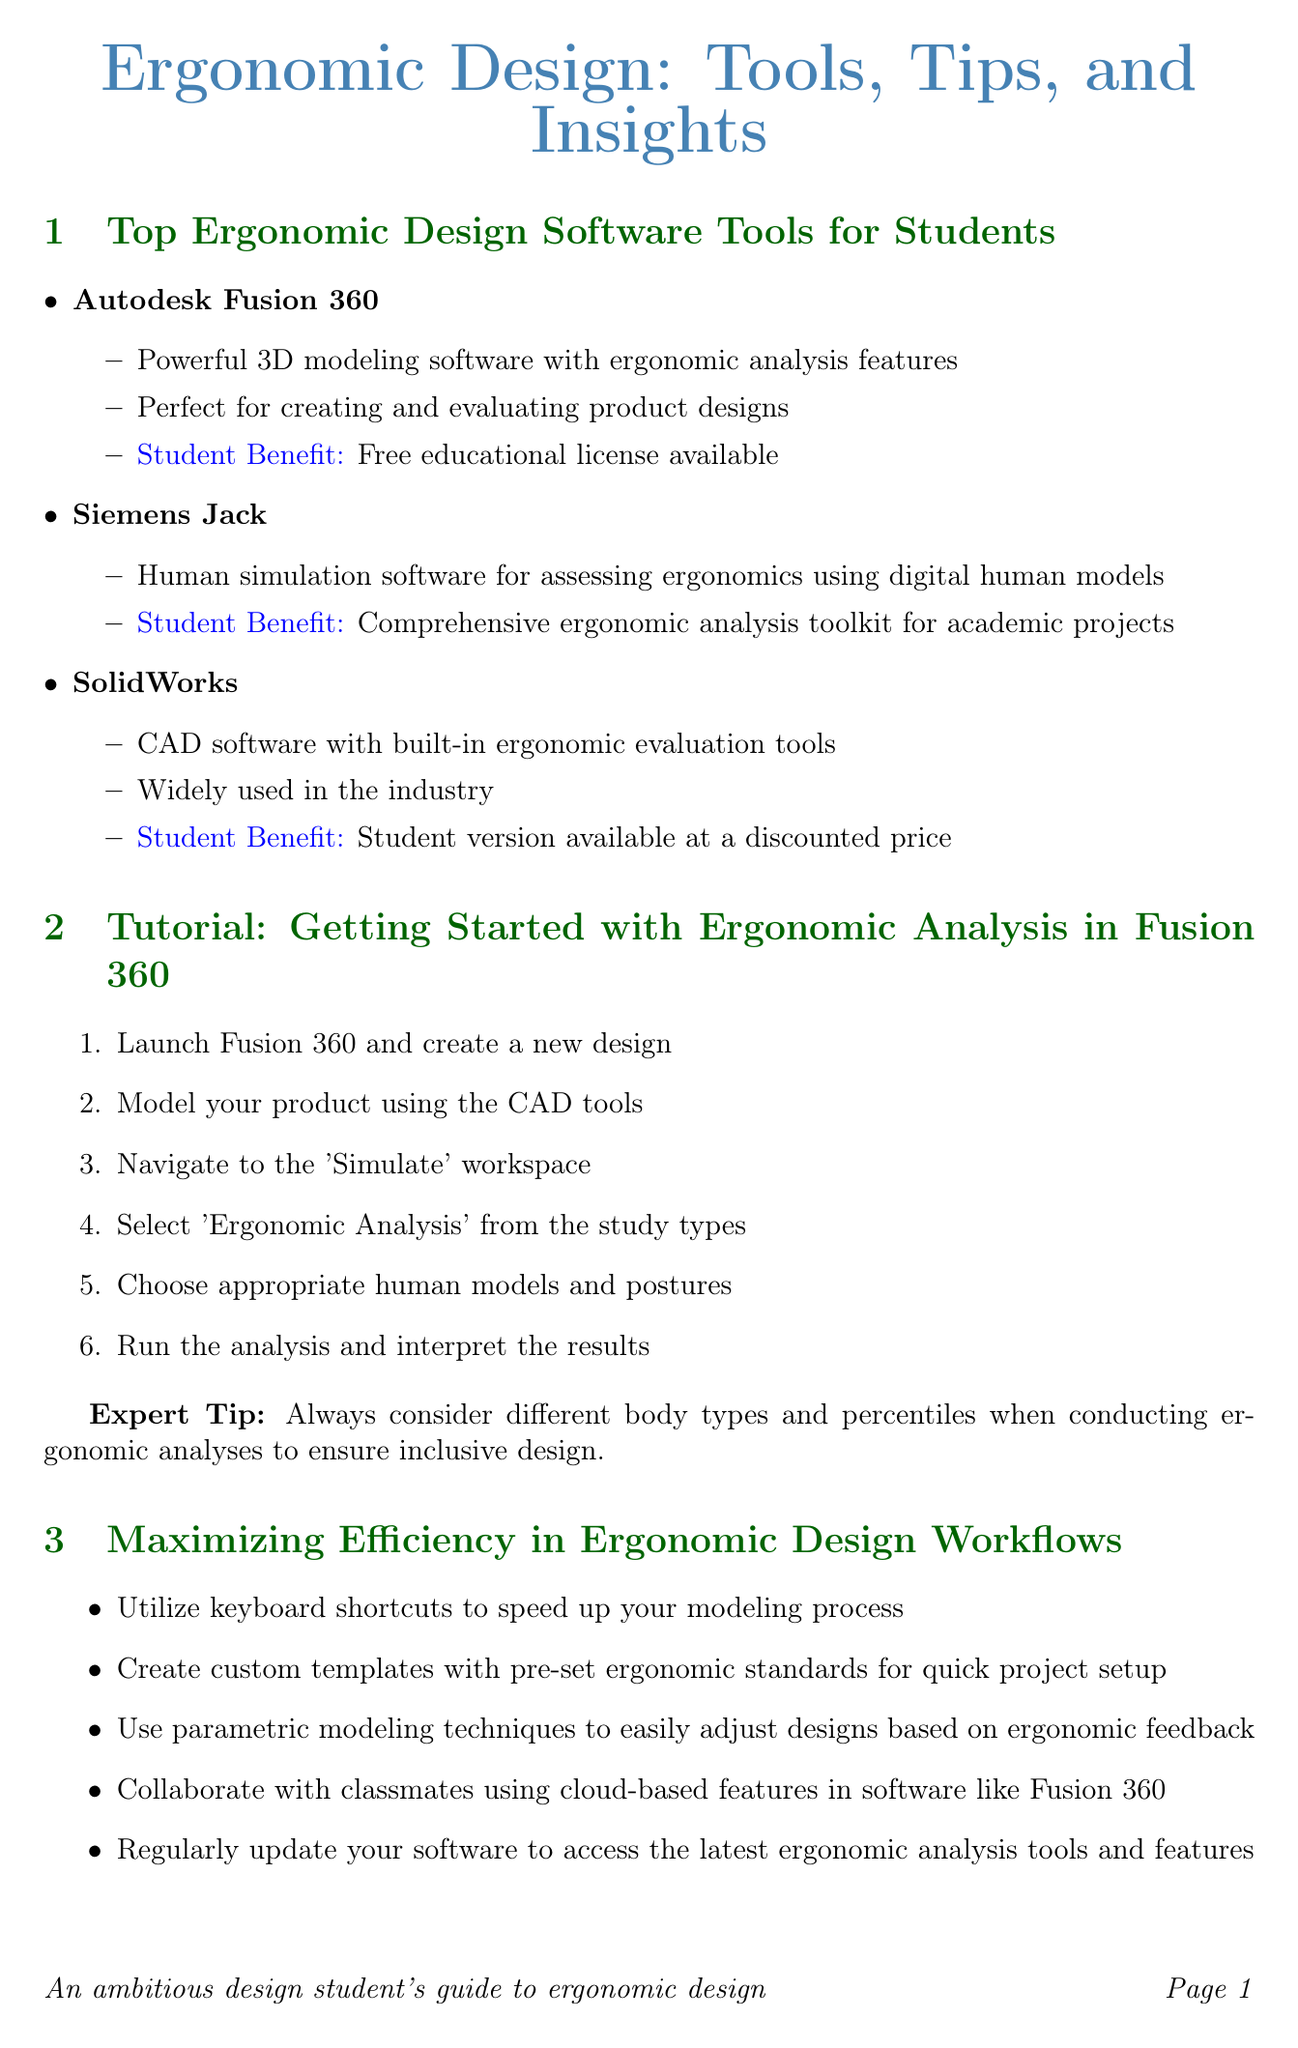What is the software used in the case study? The software used by Herman Miller for the Aeron Chair is a proprietary ergonomic simulation software.
Answer: Proprietary ergonomic simulation software What is the date of the Ergonomics in Product Design Masterclass? The newsletter provides the date for the masterclass as June 15, 2023.
Answer: June 15, 2023 Which software offers a free educational license for students? The document states that Autodesk Fusion 360 has a free educational license available for students.
Answer: Autodesk Fusion 360 What is one key learning from the case study of the Aeron Chair? The document mentions that the key learning is the importance of iterative testing and refinement in ergonomic design.
Answer: Iterative testing and refinement What is the location of the Siemens Jack Hands-On Workshop? The newsletter indicates that the workshop will take place at the Design Institute of Technology in New York.
Answer: Design Institute of Technology, New York Name one tip for maximizing efficiency in ergonomic design workflows. The document lists various tips, one of which is to utilize keyboard shortcuts to speed up the modeling process.
Answer: Utilize keyboard shortcuts How many steps are in the tutorial for getting started with ergonomic analysis in Fusion 360? The tutorial outlines six steps to follow for performing ergonomic analysis in Fusion 360.
Answer: Six steps What type of workshop is scheduled for July 8-9, 2023? The newsletter describes the event as a hands-on workshop focused on using Siemens Jack for ergonomic analysis.
Answer: Hands-On Workshop 